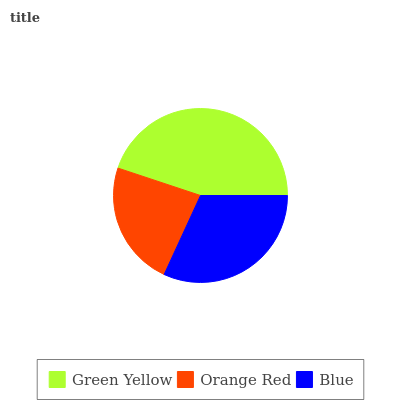Is Orange Red the minimum?
Answer yes or no. Yes. Is Green Yellow the maximum?
Answer yes or no. Yes. Is Blue the minimum?
Answer yes or no. No. Is Blue the maximum?
Answer yes or no. No. Is Blue greater than Orange Red?
Answer yes or no. Yes. Is Orange Red less than Blue?
Answer yes or no. Yes. Is Orange Red greater than Blue?
Answer yes or no. No. Is Blue less than Orange Red?
Answer yes or no. No. Is Blue the high median?
Answer yes or no. Yes. Is Blue the low median?
Answer yes or no. Yes. Is Orange Red the high median?
Answer yes or no. No. Is Orange Red the low median?
Answer yes or no. No. 